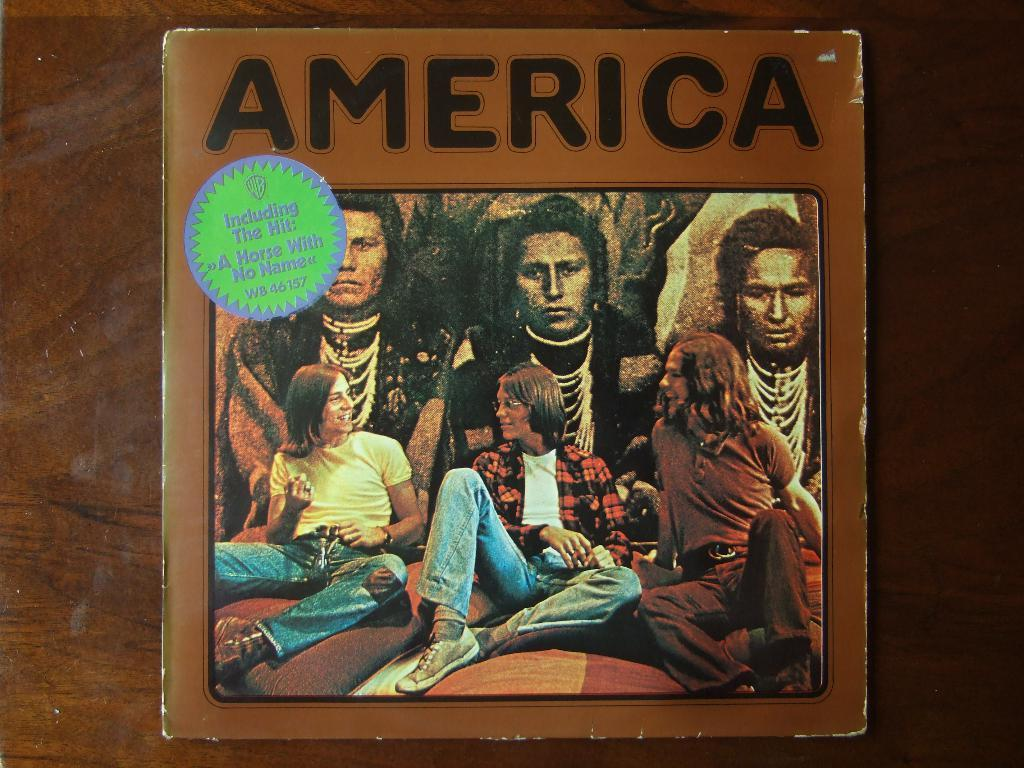<image>
Present a compact description of the photo's key features. The America album cover which includes the hit A Horse with No Name. 